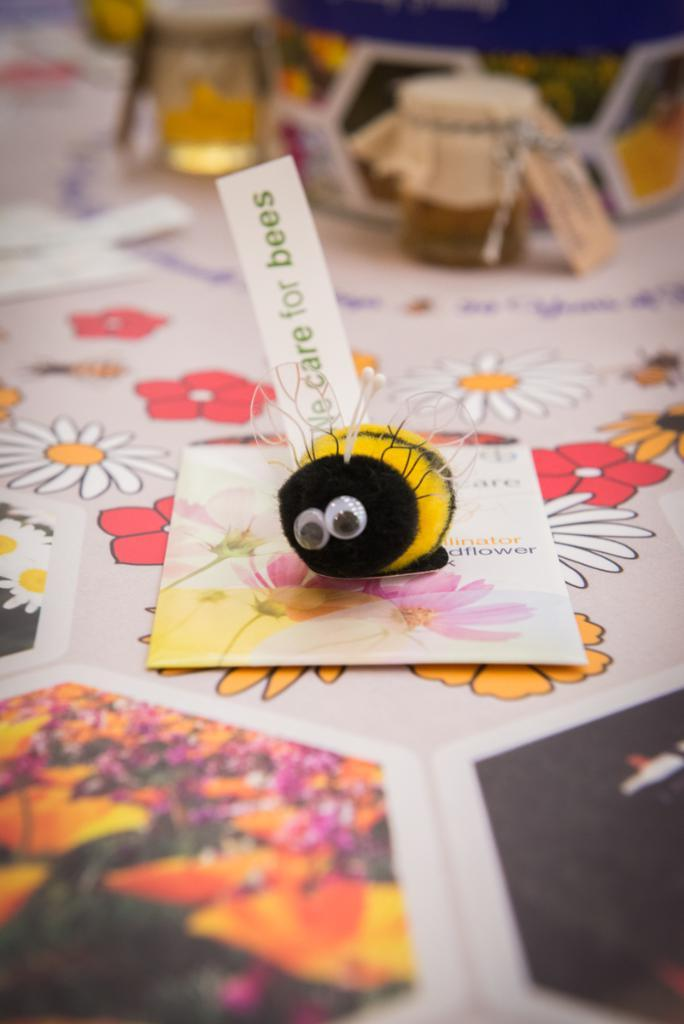<image>
Present a compact description of the photo's key features. A bee craft with a label that reads " No care for bees". 